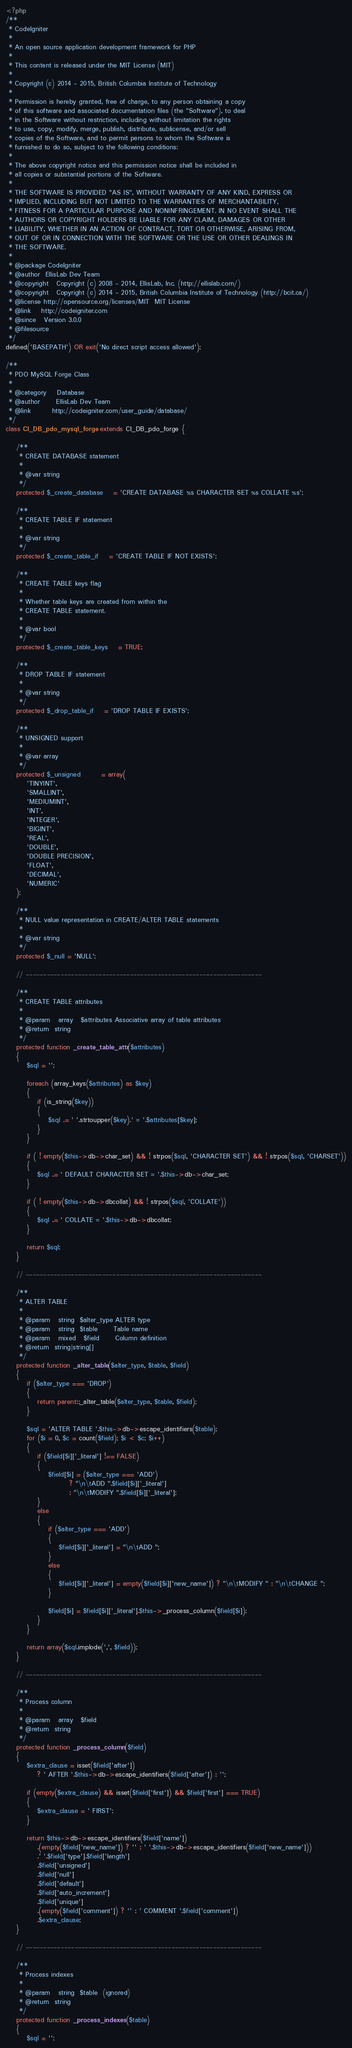<code> <loc_0><loc_0><loc_500><loc_500><_PHP_><?php
/**
 * CodeIgniter
 *
 * An open source application development framework for PHP
 *
 * This content is released under the MIT License (MIT)
 *
 * Copyright (c) 2014 - 2015, British Columbia Institute of Technology
 *
 * Permission is hereby granted, free of charge, to any person obtaining a copy
 * of this software and associated documentation files (the "Software"), to deal
 * in the Software without restriction, including without limitation the rights
 * to use, copy, modify, merge, publish, distribute, sublicense, and/or sell
 * copies of the Software, and to permit persons to whom the Software is
 * furnished to do so, subject to the following conditions:
 *
 * The above copyright notice and this permission notice shall be included in
 * all copies or substantial portions of the Software.
 *
 * THE SOFTWARE IS PROVIDED "AS IS", WITHOUT WARRANTY OF ANY KIND, EXPRESS OR
 * IMPLIED, INCLUDING BUT NOT LIMITED TO THE WARRANTIES OF MERCHANTABILITY,
 * FITNESS FOR A PARTICULAR PURPOSE AND NONINFRINGEMENT. IN NO EVENT SHALL THE
 * AUTHORS OR COPYRIGHT HOLDERS BE LIABLE FOR ANY CLAIM, DAMAGES OR OTHER
 * LIABILITY, WHETHER IN AN ACTION OF CONTRACT, TORT OR OTHERWISE, ARISING FROM,
 * OUT OF OR IN CONNECTION WITH THE SOFTWARE OR THE USE OR OTHER DEALINGS IN
 * THE SOFTWARE.
 *
 * @package	CodeIgniter
 * @author	EllisLab Dev Team
 * @copyright	Copyright (c) 2008 - 2014, EllisLab, Inc. (http://ellislab.com/)
 * @copyright	Copyright (c) 2014 - 2015, British Columbia Institute of Technology (http://bcit.ca/)
 * @license	http://opensource.org/licenses/MIT	MIT License
 * @link	http://codeigniter.com
 * @since	Version 3.0.0
 * @filesource
 */
defined('BASEPATH') OR exit('No direct script access allowed');

/**
 * PDO MySQL Forge Class
 *
 * @category	Database
 * @author		EllisLab Dev Team
 * @link		http://codeigniter.com/user_guide/database/
 */
class CI_DB_pdo_mysql_forge extends CI_DB_pdo_forge {

	/**
	 * CREATE DATABASE statement
	 *
	 * @var	string
	 */
	protected $_create_database	= 'CREATE DATABASE %s CHARACTER SET %s COLLATE %s';

	/**
	 * CREATE TABLE IF statement
	 *
	 * @var	string
	 */
	protected $_create_table_if	= 'CREATE TABLE IF NOT EXISTS';

	/**
	 * CREATE TABLE keys flag
	 *
	 * Whether table keys are created from within the
	 * CREATE TABLE statement.
	 *
	 * @var	bool
	 */
	protected $_create_table_keys	= TRUE;

	/**
	 * DROP TABLE IF statement
	 *
	 * @var	string
	 */
	protected $_drop_table_if	= 'DROP TABLE IF EXISTS';

	/**
	 * UNSIGNED support
	 *
	 * @var	array
	 */
	protected $_unsigned		= array(
		'TINYINT',
		'SMALLINT',
		'MEDIUMINT',
		'INT',
		'INTEGER',
		'BIGINT',
		'REAL',
		'DOUBLE',
		'DOUBLE PRECISION',
		'FLOAT',
		'DECIMAL',
		'NUMERIC'
	);

	/**
	 * NULL value representation in CREATE/ALTER TABLE statements
	 *
	 * @var	string
	 */
	protected $_null = 'NULL';

	// --------------------------------------------------------------------

	/**
	 * CREATE TABLE attributes
	 *
	 * @param	array	$attributes	Associative array of table attributes
	 * @return	string
	 */
	protected function _create_table_attr($attributes)
	{
		$sql = '';

		foreach (array_keys($attributes) as $key)
		{
			if (is_string($key))
			{
				$sql .= ' '.strtoupper($key).' = '.$attributes[$key];
			}
		}

		if ( ! empty($this->db->char_set) && ! strpos($sql, 'CHARACTER SET') && ! strpos($sql, 'CHARSET'))
		{
			$sql .= ' DEFAULT CHARACTER SET = '.$this->db->char_set;
		}

		if ( ! empty($this->db->dbcollat) && ! strpos($sql, 'COLLATE'))
		{
			$sql .= ' COLLATE = '.$this->db->dbcollat;
		}

		return $sql;
	}

	// --------------------------------------------------------------------

	/**
	 * ALTER TABLE
	 *
	 * @param	string	$alter_type	ALTER type
	 * @param	string	$table		Table name
	 * @param	mixed	$field		Column definition
	 * @return	string|string[]
	 */
	protected function _alter_table($alter_type, $table, $field)
	{
		if ($alter_type === 'DROP')
		{
			return parent::_alter_table($alter_type, $table, $field);
		}

		$sql = 'ALTER TABLE '.$this->db->escape_identifiers($table);
		for ($i = 0, $c = count($field); $i < $c; $i++)
		{
			if ($field[$i]['_literal'] !== FALSE)
			{
				$field[$i] = ($alter_type === 'ADD')
						? "\n\tADD ".$field[$i]['_literal']
						: "\n\tMODIFY ".$field[$i]['_literal'];
			}
			else
			{
				if ($alter_type === 'ADD')
				{
					$field[$i]['_literal'] = "\n\tADD ";
				}
				else
				{
					$field[$i]['_literal'] = empty($field[$i]['new_name']) ? "\n\tMODIFY " : "\n\tCHANGE ";
				}

				$field[$i] = $field[$i]['_literal'].$this->_process_column($field[$i]);
			}
		}

		return array($sql.implode(',', $field));
	}

	// --------------------------------------------------------------------

	/**
	 * Process column
	 *
	 * @param	array	$field
	 * @return	string
	 */
	protected function _process_column($field)
	{
		$extra_clause = isset($field['after'])
			? ' AFTER '.$this->db->escape_identifiers($field['after']) : '';

		if (empty($extra_clause) && isset($field['first']) && $field['first'] === TRUE)
		{
			$extra_clause = ' FIRST';
		}

		return $this->db->escape_identifiers($field['name'])
			.(empty($field['new_name']) ? '' : ' '.$this->db->escape_identifiers($field['new_name']))
			.' '.$field['type'].$field['length']
			.$field['unsigned']
			.$field['null']
			.$field['default']
			.$field['auto_increment']
			.$field['unique']
			.(empty($field['comment']) ? '' : ' COMMENT '.$field['comment'])
			.$extra_clause;
	}

	// --------------------------------------------------------------------

	/**
	 * Process indexes
	 *
	 * @param	string	$table	(ignored)
	 * @return	string
	 */
	protected function _process_indexes($table)
	{
		$sql = '';
</code> 